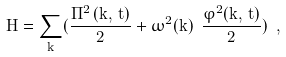<formula> <loc_0><loc_0><loc_500><loc_500>H = \sum _ { \vec { k } } ( \frac { \Pi ^ { 2 } \, ( \vec { k } , \, t ) } { 2 } + \omega ^ { 2 } ( \vec { k } ) \ \frac { \varphi ^ { 2 } ( \vec { k } , \, t ) } { 2 } ) \ ,</formula> 